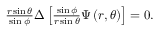Convert formula to latex. <formula><loc_0><loc_0><loc_500><loc_500>\begin{array} { r } { \frac { r \sin \theta } { \sin \phi } \Delta \left [ \frac { \sin \phi } { r \sin \theta } \Psi \left ( r , \theta \right ) \right ] = 0 . } \end{array}</formula> 